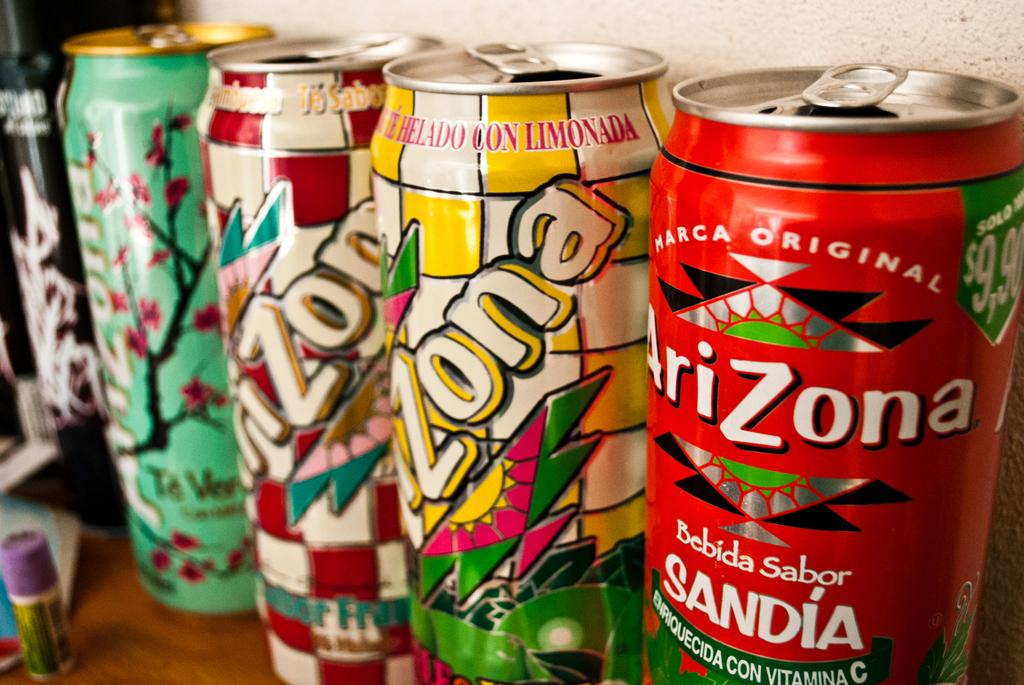What brand are the canned drinks?
Provide a short and direct response. Arizona. What is the right brand of drink?
Provide a succinct answer. Arizona. 